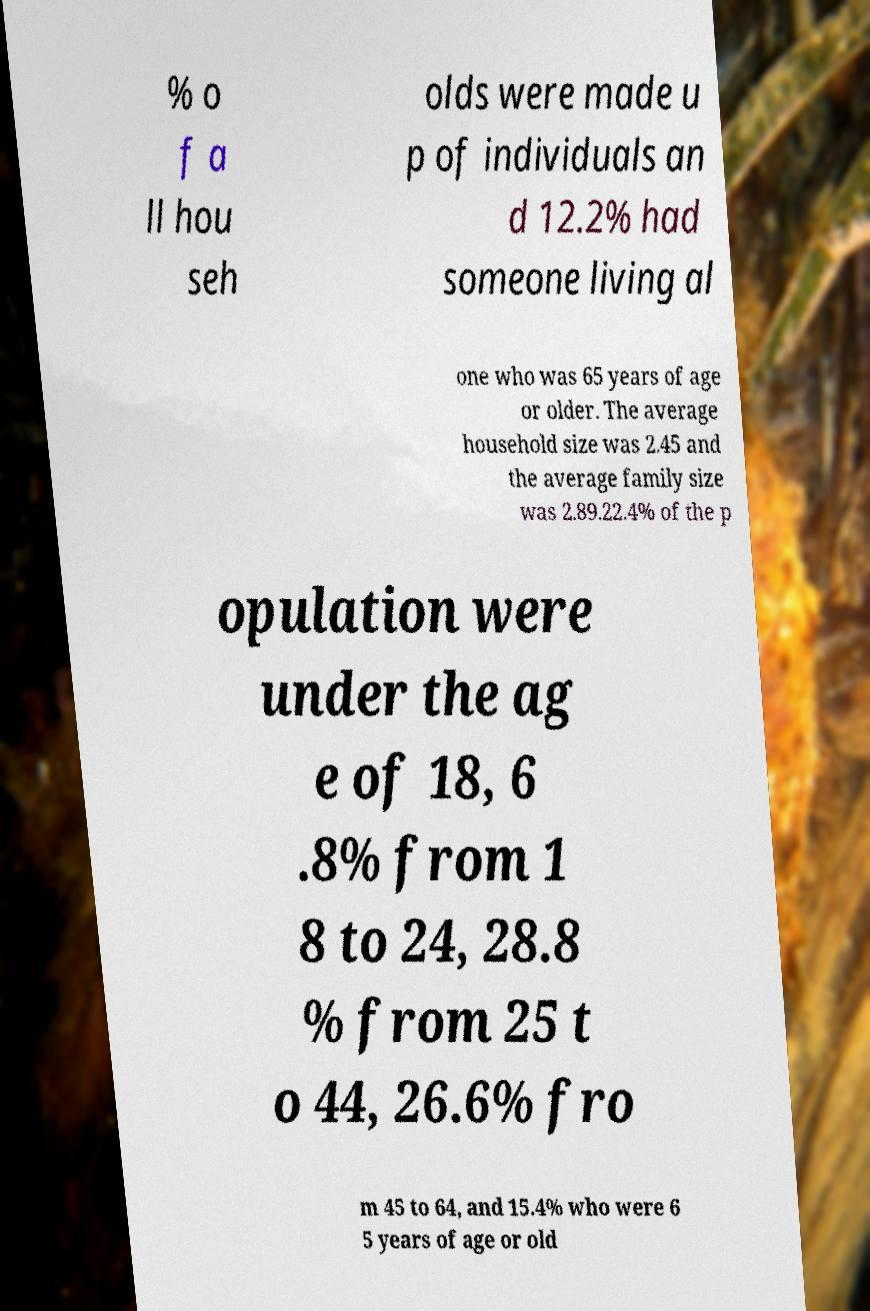Please identify and transcribe the text found in this image. % o f a ll hou seh olds were made u p of individuals an d 12.2% had someone living al one who was 65 years of age or older. The average household size was 2.45 and the average family size was 2.89.22.4% of the p opulation were under the ag e of 18, 6 .8% from 1 8 to 24, 28.8 % from 25 t o 44, 26.6% fro m 45 to 64, and 15.4% who were 6 5 years of age or old 